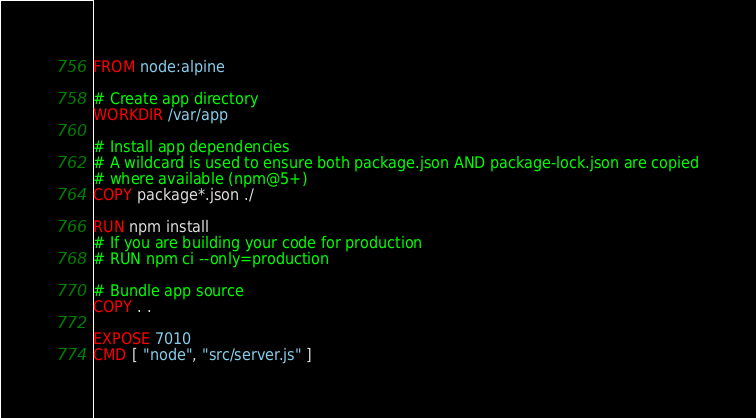<code> <loc_0><loc_0><loc_500><loc_500><_Dockerfile_>FROM node:alpine

# Create app directory
WORKDIR /var/app

# Install app dependencies
# A wildcard is used to ensure both package.json AND package-lock.json are copied
# where available (npm@5+)
COPY package*.json ./

RUN npm install
# If you are building your code for production
# RUN npm ci --only=production

# Bundle app source
COPY . .

EXPOSE 7010
CMD [ "node", "src/server.js" ]</code> 